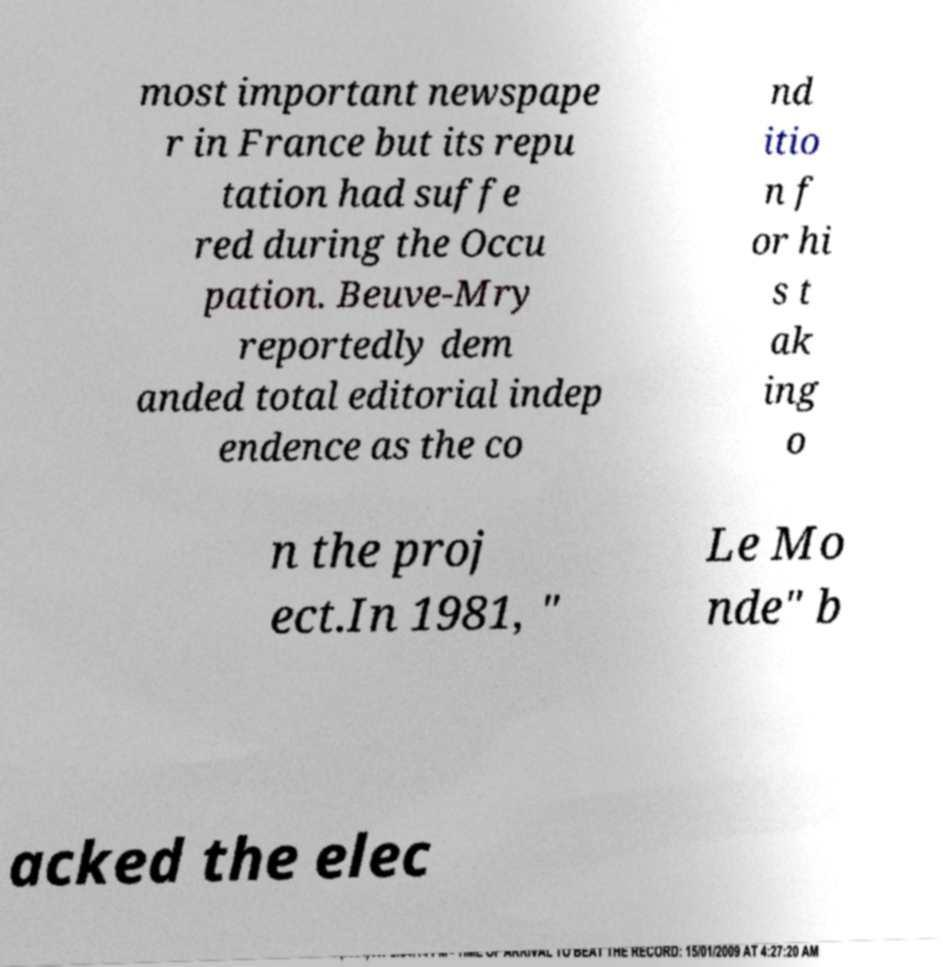What messages or text are displayed in this image? I need them in a readable, typed format. most important newspape r in France but its repu tation had suffe red during the Occu pation. Beuve-Mry reportedly dem anded total editorial indep endence as the co nd itio n f or hi s t ak ing o n the proj ect.In 1981, " Le Mo nde" b acked the elec 